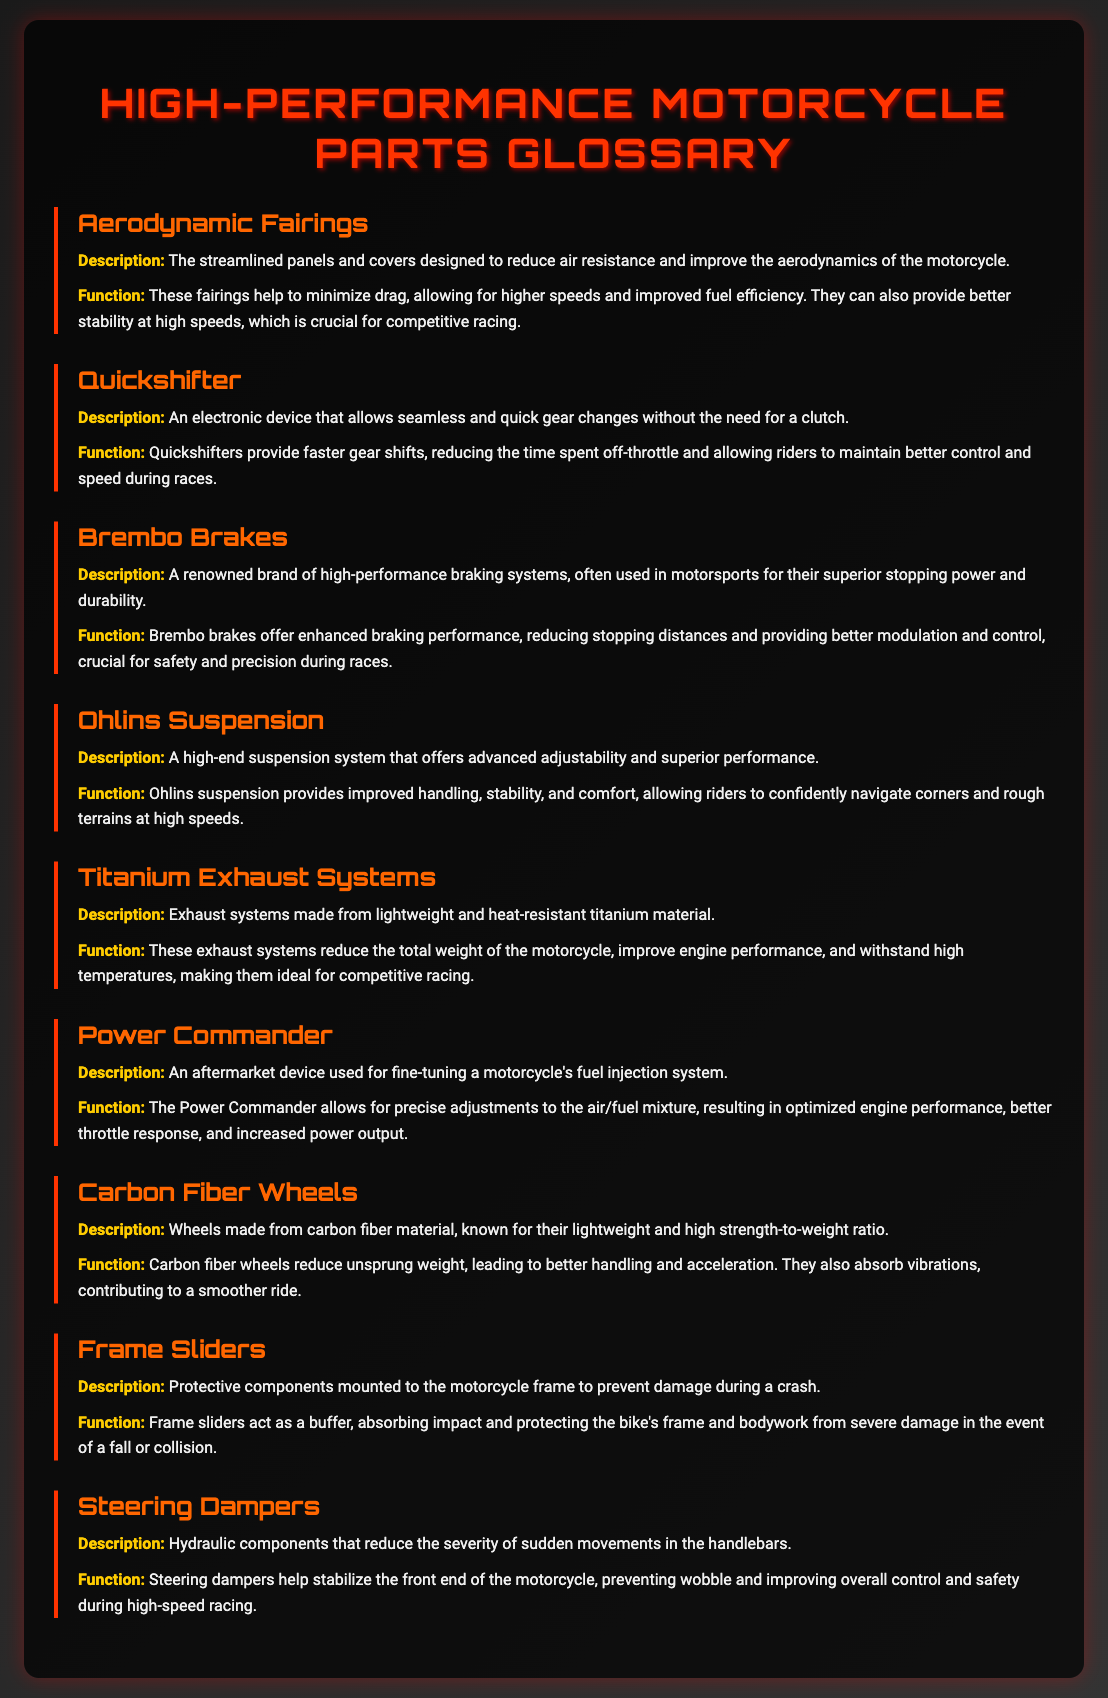What are aerodynamic fairings? Aerodynamic fairings are the streamlined panels and covers designed to reduce air resistance and improve the aerodynamics of the motorcycle.
Answer: Streamlined panels and covers What is a quickshifter? A quickshifter is an electronic device that allows seamless and quick gear changes without the need for a clutch.
Answer: Electronic device for gear changes What brand is known for high-performance braking systems? Brembo is a renowned brand of high-performance braking systems, often used in motorsports.
Answer: Brembo What is the function of titanium exhaust systems? Titanium exhaust systems reduce the total weight of the motorcycle, improve engine performance, and withstand high temperatures.
Answer: Reduce weight, improve performance What type of suspension system is Ohlins? Ohlins is a high-end suspension system that offers advanced adjustability and superior performance.
Answer: High-end suspension system How do carbon fiber wheels affect motorcycle performance? Carbon fiber wheels reduce unsprung weight, leading to better handling and acceleration.
Answer: Better handling and acceleration What is the purpose of frame sliders? Frame sliders act as a buffer, absorbing impact and protecting the bike's frame and bodywork from severe damage.
Answer: Absorb impact and protect What do steering dampers do? Steering dampers help stabilize the front end of the motorcycle, preventing wobble and improving overall control and safety.
Answer: Stabilize front end and improve control 